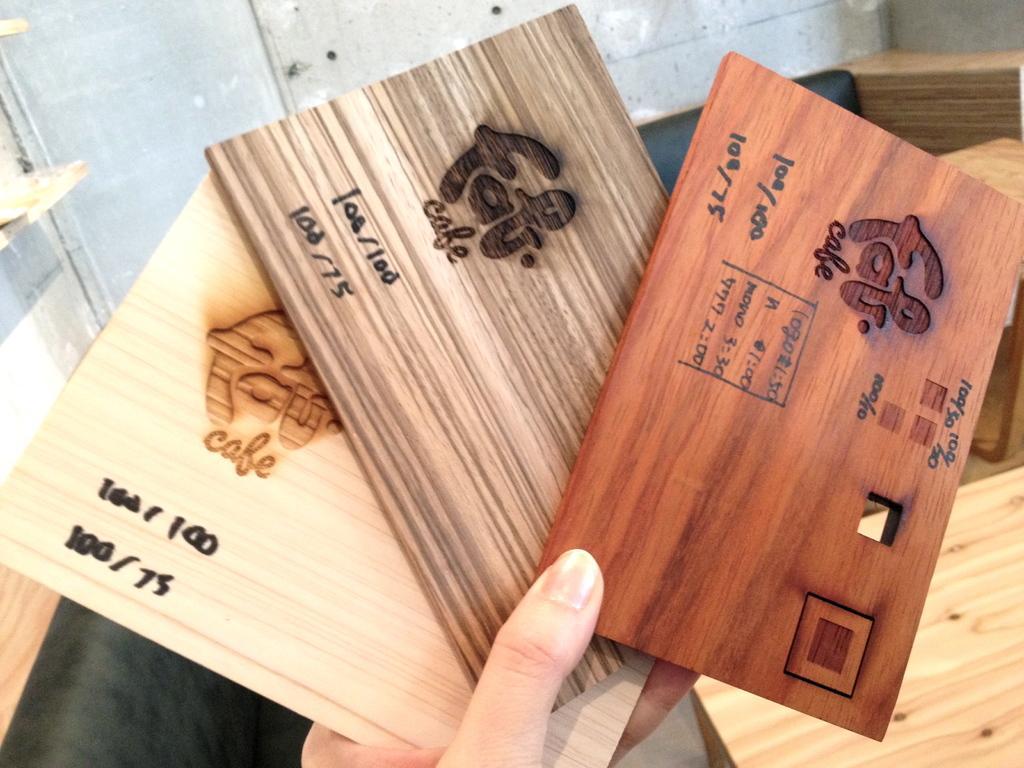Describe this image in one or two sentences. In the picture,a person is holding three wooden cards with the hand and on the card there is a cafe name and some other details are mentioned. 